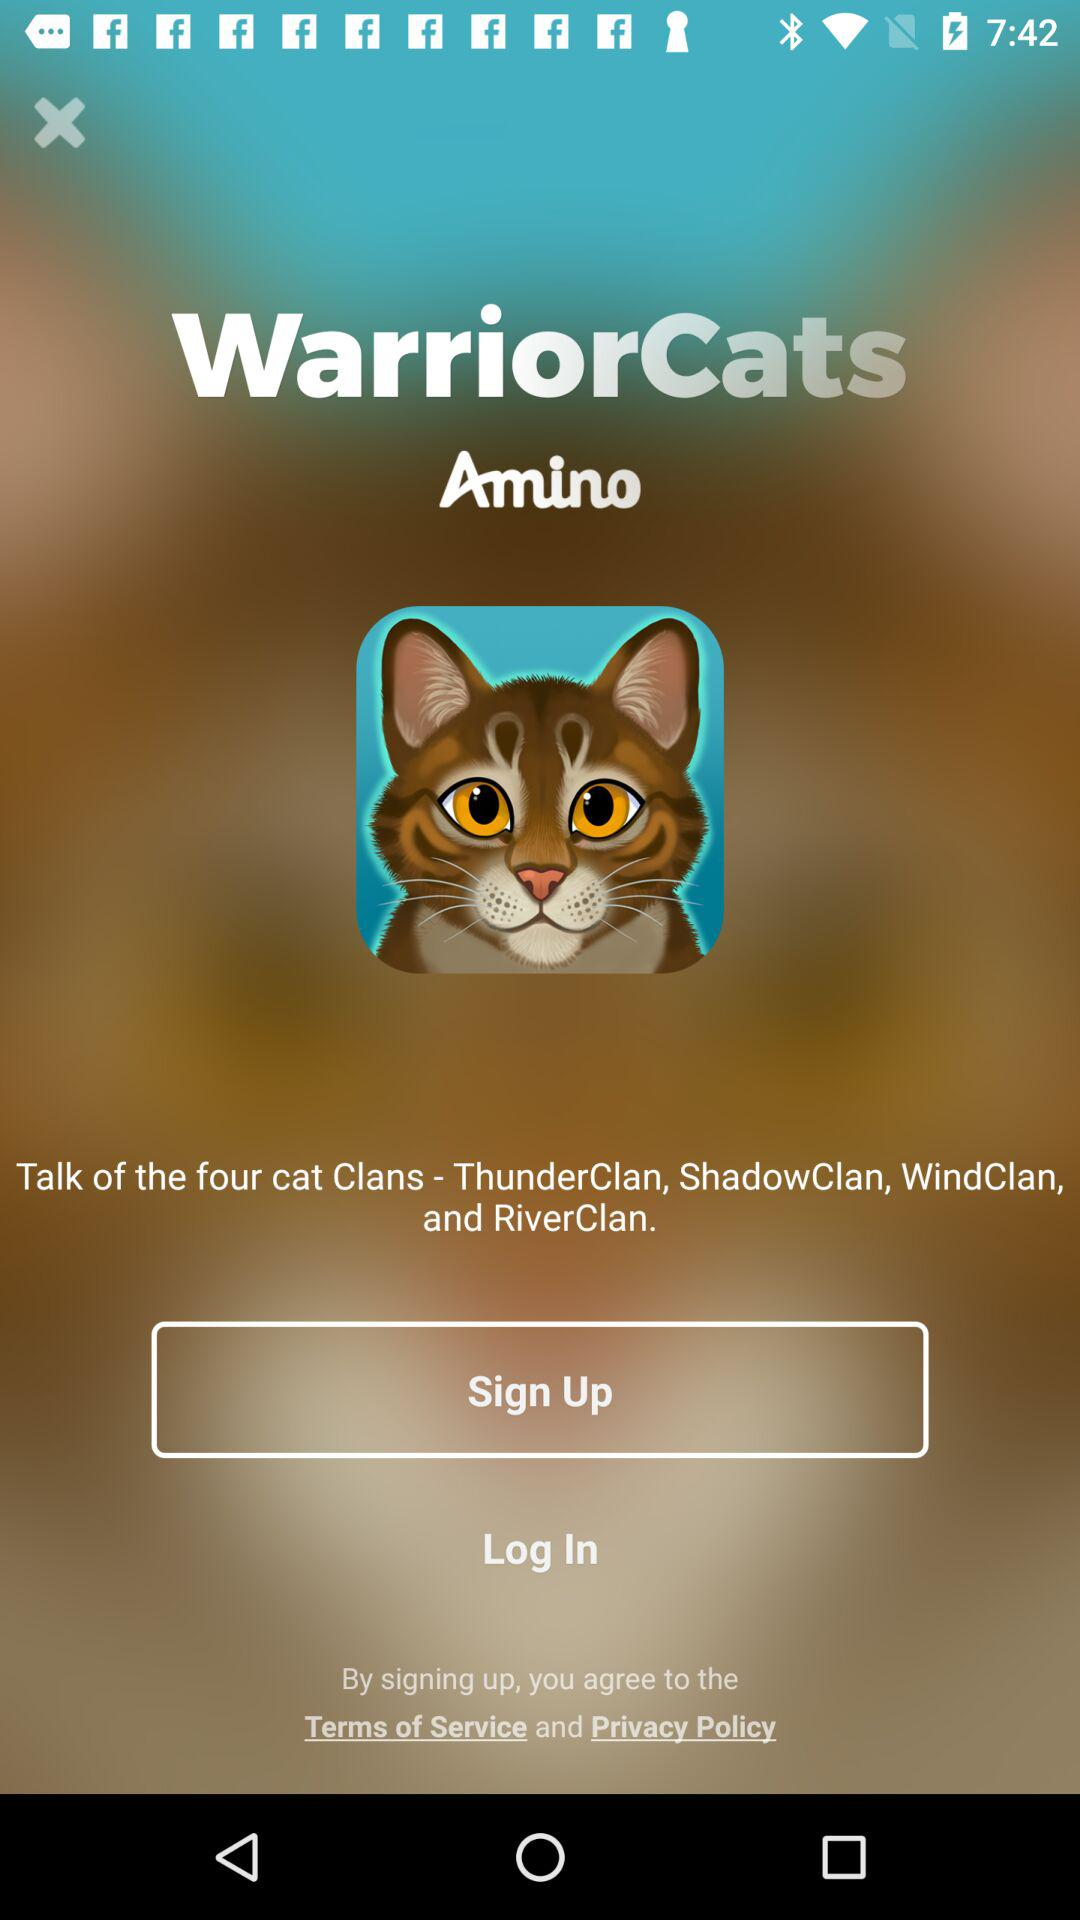What is the app name? The app name is "WarriorCats Amino". 